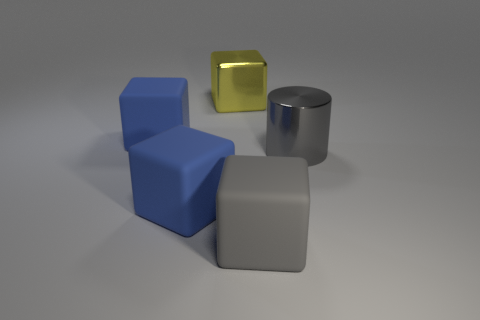Subtract all large matte blocks. How many blocks are left? 1 Subtract all red spheres. How many blue cubes are left? 2 Subtract all gray cubes. How many cubes are left? 3 Subtract all red blocks. Subtract all cyan cylinders. How many blocks are left? 4 Add 4 brown rubber spheres. How many objects exist? 9 Subtract all cylinders. How many objects are left? 4 Subtract all yellow shiny cubes. Subtract all big purple objects. How many objects are left? 4 Add 2 big cylinders. How many big cylinders are left? 3 Add 4 matte cubes. How many matte cubes exist? 7 Subtract 0 brown balls. How many objects are left? 5 